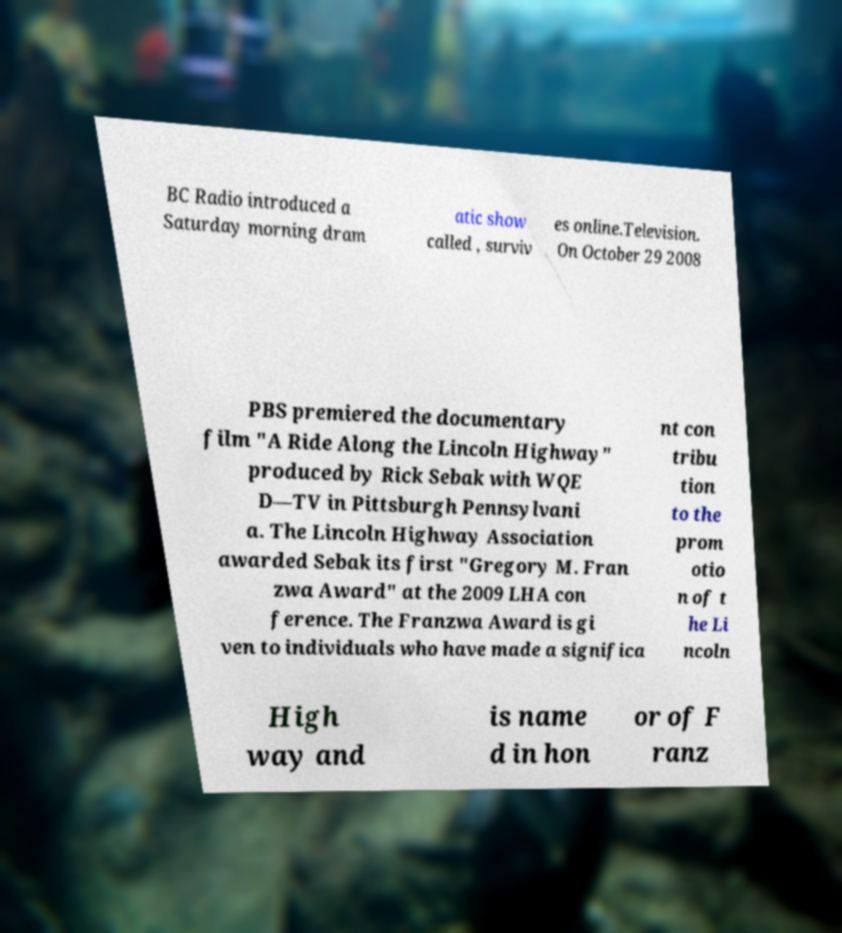Can you read and provide the text displayed in the image?This photo seems to have some interesting text. Can you extract and type it out for me? BC Radio introduced a Saturday morning dram atic show called , surviv es online.Television. On October 29 2008 PBS premiered the documentary film "A Ride Along the Lincoln Highway" produced by Rick Sebak with WQE D—TV in Pittsburgh Pennsylvani a. The Lincoln Highway Association awarded Sebak its first "Gregory M. Fran zwa Award" at the 2009 LHA con ference. The Franzwa Award is gi ven to individuals who have made a significa nt con tribu tion to the prom otio n of t he Li ncoln High way and is name d in hon or of F ranz 